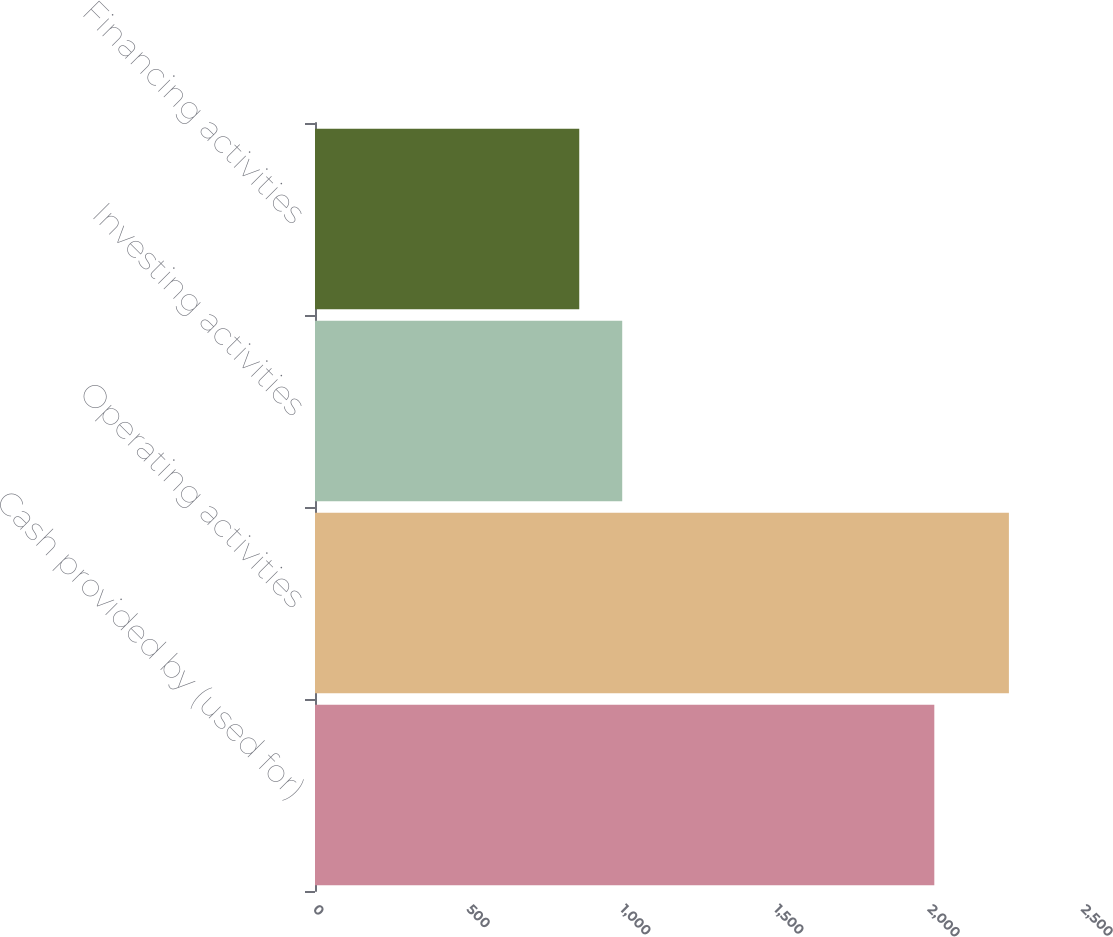Convert chart to OTSL. <chart><loc_0><loc_0><loc_500><loc_500><bar_chart><fcel>Cash provided by (used for)<fcel>Operating activities<fcel>Investing activities<fcel>Financing activities<nl><fcel>2016<fcel>2258.8<fcel>1000.06<fcel>860.2<nl></chart> 